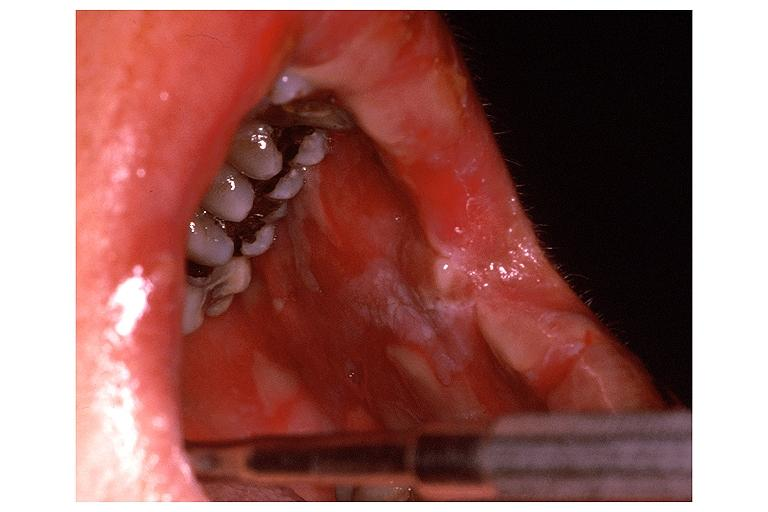what does this image show?
Answer the question using a single word or phrase. Erythema multiforme 